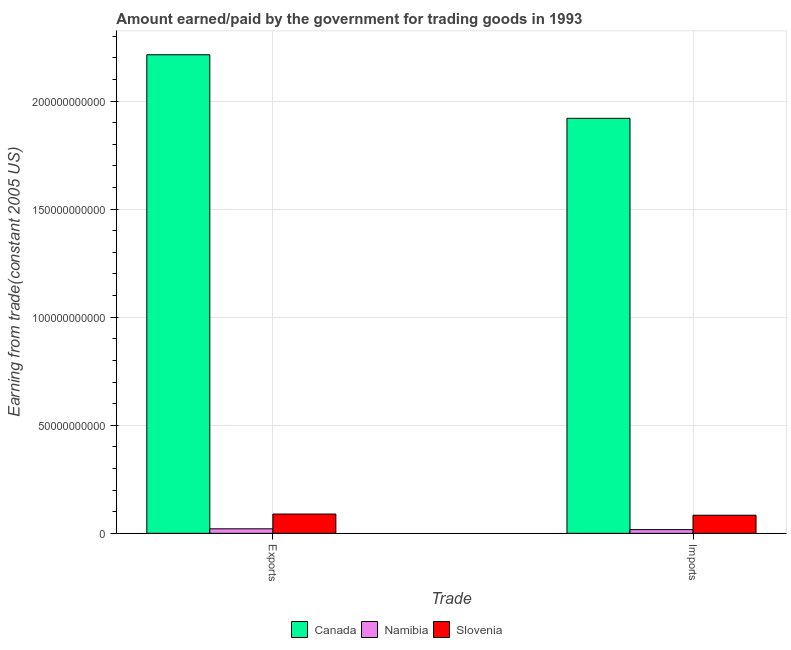How many bars are there on the 1st tick from the left?
Offer a terse response. 3. How many bars are there on the 2nd tick from the right?
Provide a succinct answer. 3. What is the label of the 2nd group of bars from the left?
Keep it short and to the point. Imports. What is the amount earned from exports in Canada?
Provide a short and direct response. 2.21e+11. Across all countries, what is the maximum amount earned from exports?
Provide a short and direct response. 2.21e+11. Across all countries, what is the minimum amount earned from exports?
Make the answer very short. 2.09e+09. In which country was the amount earned from exports maximum?
Make the answer very short. Canada. In which country was the amount paid for imports minimum?
Provide a short and direct response. Namibia. What is the total amount paid for imports in the graph?
Your response must be concise. 2.02e+11. What is the difference between the amount earned from exports in Namibia and that in Canada?
Offer a very short reply. -2.19e+11. What is the difference between the amount paid for imports in Canada and the amount earned from exports in Slovenia?
Your response must be concise. 1.83e+11. What is the average amount paid for imports per country?
Give a very brief answer. 6.74e+1. What is the difference between the amount earned from exports and amount paid for imports in Namibia?
Keep it short and to the point. 3.80e+08. In how many countries, is the amount earned from exports greater than 140000000000 US$?
Your answer should be compact. 1. What is the ratio of the amount paid for imports in Slovenia to that in Canada?
Offer a very short reply. 0.04. Is the amount earned from exports in Namibia less than that in Canada?
Your answer should be compact. Yes. In how many countries, is the amount paid for imports greater than the average amount paid for imports taken over all countries?
Provide a short and direct response. 1. What does the 2nd bar from the left in Exports represents?
Offer a very short reply. Namibia. How many bars are there?
Offer a terse response. 6. Are all the bars in the graph horizontal?
Keep it short and to the point. No. How many countries are there in the graph?
Your response must be concise. 3. What is the difference between two consecutive major ticks on the Y-axis?
Your answer should be very brief. 5.00e+1. Are the values on the major ticks of Y-axis written in scientific E-notation?
Offer a terse response. No. Does the graph contain any zero values?
Provide a succinct answer. No. Does the graph contain grids?
Offer a very short reply. Yes. Where does the legend appear in the graph?
Make the answer very short. Bottom center. How many legend labels are there?
Provide a succinct answer. 3. How are the legend labels stacked?
Ensure brevity in your answer.  Horizontal. What is the title of the graph?
Provide a succinct answer. Amount earned/paid by the government for trading goods in 1993. Does "Tonga" appear as one of the legend labels in the graph?
Your answer should be compact. No. What is the label or title of the X-axis?
Provide a short and direct response. Trade. What is the label or title of the Y-axis?
Keep it short and to the point. Earning from trade(constant 2005 US). What is the Earning from trade(constant 2005 US) of Canada in Exports?
Ensure brevity in your answer.  2.21e+11. What is the Earning from trade(constant 2005 US) of Namibia in Exports?
Your response must be concise. 2.09e+09. What is the Earning from trade(constant 2005 US) of Slovenia in Exports?
Ensure brevity in your answer.  8.93e+09. What is the Earning from trade(constant 2005 US) of Canada in Imports?
Your response must be concise. 1.92e+11. What is the Earning from trade(constant 2005 US) of Namibia in Imports?
Your answer should be very brief. 1.71e+09. What is the Earning from trade(constant 2005 US) of Slovenia in Imports?
Offer a very short reply. 8.38e+09. Across all Trade, what is the maximum Earning from trade(constant 2005 US) of Canada?
Ensure brevity in your answer.  2.21e+11. Across all Trade, what is the maximum Earning from trade(constant 2005 US) in Namibia?
Provide a succinct answer. 2.09e+09. Across all Trade, what is the maximum Earning from trade(constant 2005 US) in Slovenia?
Give a very brief answer. 8.93e+09. Across all Trade, what is the minimum Earning from trade(constant 2005 US) in Canada?
Make the answer very short. 1.92e+11. Across all Trade, what is the minimum Earning from trade(constant 2005 US) of Namibia?
Provide a short and direct response. 1.71e+09. Across all Trade, what is the minimum Earning from trade(constant 2005 US) of Slovenia?
Offer a terse response. 8.38e+09. What is the total Earning from trade(constant 2005 US) in Canada in the graph?
Offer a very short reply. 4.13e+11. What is the total Earning from trade(constant 2005 US) of Namibia in the graph?
Provide a short and direct response. 3.81e+09. What is the total Earning from trade(constant 2005 US) in Slovenia in the graph?
Your response must be concise. 1.73e+1. What is the difference between the Earning from trade(constant 2005 US) of Canada in Exports and that in Imports?
Provide a succinct answer. 2.94e+1. What is the difference between the Earning from trade(constant 2005 US) in Namibia in Exports and that in Imports?
Make the answer very short. 3.80e+08. What is the difference between the Earning from trade(constant 2005 US) in Slovenia in Exports and that in Imports?
Ensure brevity in your answer.  5.49e+08. What is the difference between the Earning from trade(constant 2005 US) of Canada in Exports and the Earning from trade(constant 2005 US) of Namibia in Imports?
Provide a succinct answer. 2.20e+11. What is the difference between the Earning from trade(constant 2005 US) of Canada in Exports and the Earning from trade(constant 2005 US) of Slovenia in Imports?
Ensure brevity in your answer.  2.13e+11. What is the difference between the Earning from trade(constant 2005 US) in Namibia in Exports and the Earning from trade(constant 2005 US) in Slovenia in Imports?
Your response must be concise. -6.29e+09. What is the average Earning from trade(constant 2005 US) in Canada per Trade?
Your answer should be very brief. 2.07e+11. What is the average Earning from trade(constant 2005 US) in Namibia per Trade?
Your answer should be compact. 1.90e+09. What is the average Earning from trade(constant 2005 US) in Slovenia per Trade?
Keep it short and to the point. 8.66e+09. What is the difference between the Earning from trade(constant 2005 US) in Canada and Earning from trade(constant 2005 US) in Namibia in Exports?
Keep it short and to the point. 2.19e+11. What is the difference between the Earning from trade(constant 2005 US) in Canada and Earning from trade(constant 2005 US) in Slovenia in Exports?
Your answer should be very brief. 2.13e+11. What is the difference between the Earning from trade(constant 2005 US) of Namibia and Earning from trade(constant 2005 US) of Slovenia in Exports?
Your answer should be compact. -6.84e+09. What is the difference between the Earning from trade(constant 2005 US) of Canada and Earning from trade(constant 2005 US) of Namibia in Imports?
Keep it short and to the point. 1.90e+11. What is the difference between the Earning from trade(constant 2005 US) of Canada and Earning from trade(constant 2005 US) of Slovenia in Imports?
Provide a succinct answer. 1.84e+11. What is the difference between the Earning from trade(constant 2005 US) of Namibia and Earning from trade(constant 2005 US) of Slovenia in Imports?
Offer a terse response. -6.67e+09. What is the ratio of the Earning from trade(constant 2005 US) in Canada in Exports to that in Imports?
Provide a succinct answer. 1.15. What is the ratio of the Earning from trade(constant 2005 US) in Namibia in Exports to that in Imports?
Make the answer very short. 1.22. What is the ratio of the Earning from trade(constant 2005 US) in Slovenia in Exports to that in Imports?
Offer a very short reply. 1.07. What is the difference between the highest and the second highest Earning from trade(constant 2005 US) in Canada?
Your answer should be very brief. 2.94e+1. What is the difference between the highest and the second highest Earning from trade(constant 2005 US) of Namibia?
Your response must be concise. 3.80e+08. What is the difference between the highest and the second highest Earning from trade(constant 2005 US) in Slovenia?
Your answer should be compact. 5.49e+08. What is the difference between the highest and the lowest Earning from trade(constant 2005 US) in Canada?
Provide a succinct answer. 2.94e+1. What is the difference between the highest and the lowest Earning from trade(constant 2005 US) of Namibia?
Provide a succinct answer. 3.80e+08. What is the difference between the highest and the lowest Earning from trade(constant 2005 US) of Slovenia?
Make the answer very short. 5.49e+08. 